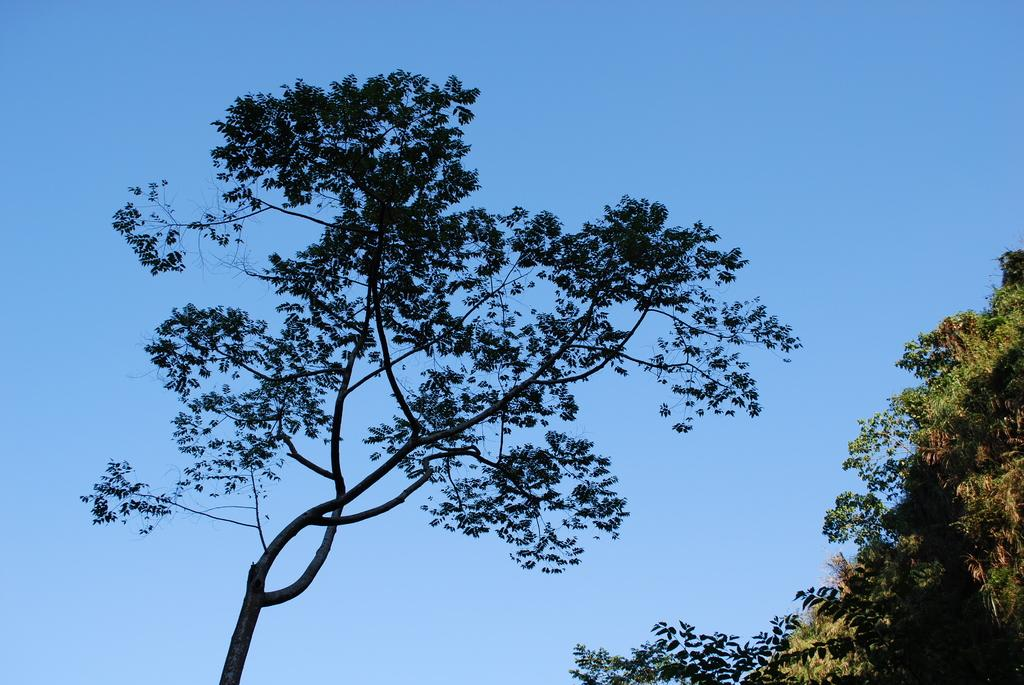What type of plant can be seen in the image? There is a tree in the image. Where are the trees located in the image? There are trees in the right bottom of the image. What can be seen in the background of the image? The sky is visible in the background of the image. What is the color of the sky in the image? The sky is blue in color. How many pens are visible in the image? There are no pens present in the image. Do the sticks in the image have any special properties? There are no sticks present in the image. 